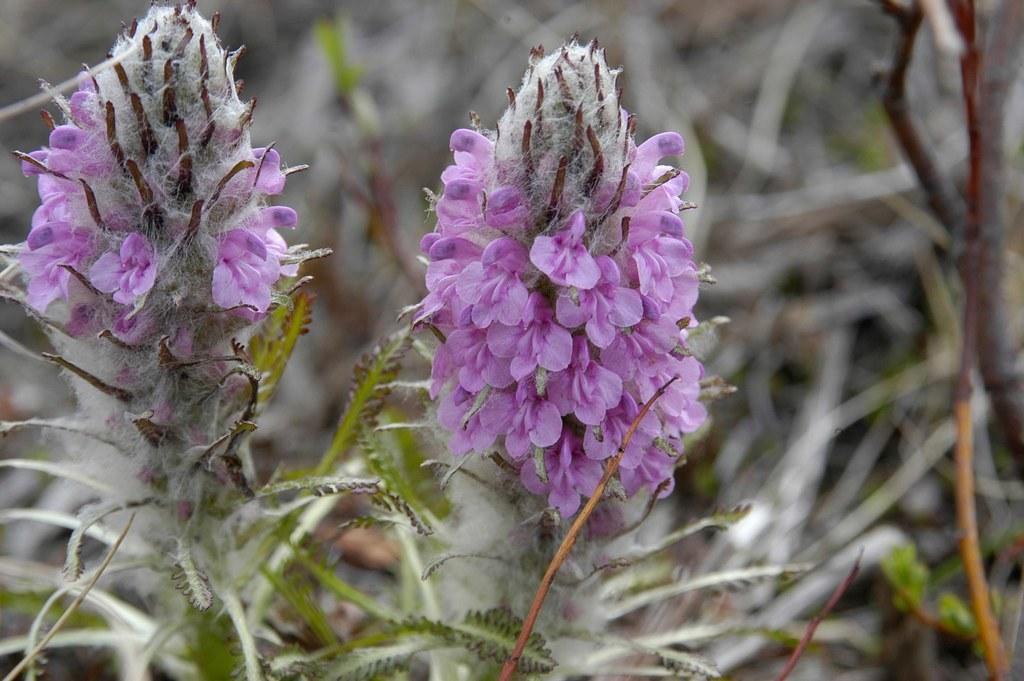What type of living organisms can be seen in the image? There are flowers and plants visible in the image. Can you describe the plants in the image? The plants in the image are not specified, but they are likely green and leafy. How many different types of living organisms are present in the image? There are two types of living organisms present in the image: flowers and plants. What type of veil can be seen covering the flowers in the image? There is no veil present in the image; the flowers are not covered. Are there any fairies visible in the image? There are no fairies present in the image; it only features flowers and plants. 